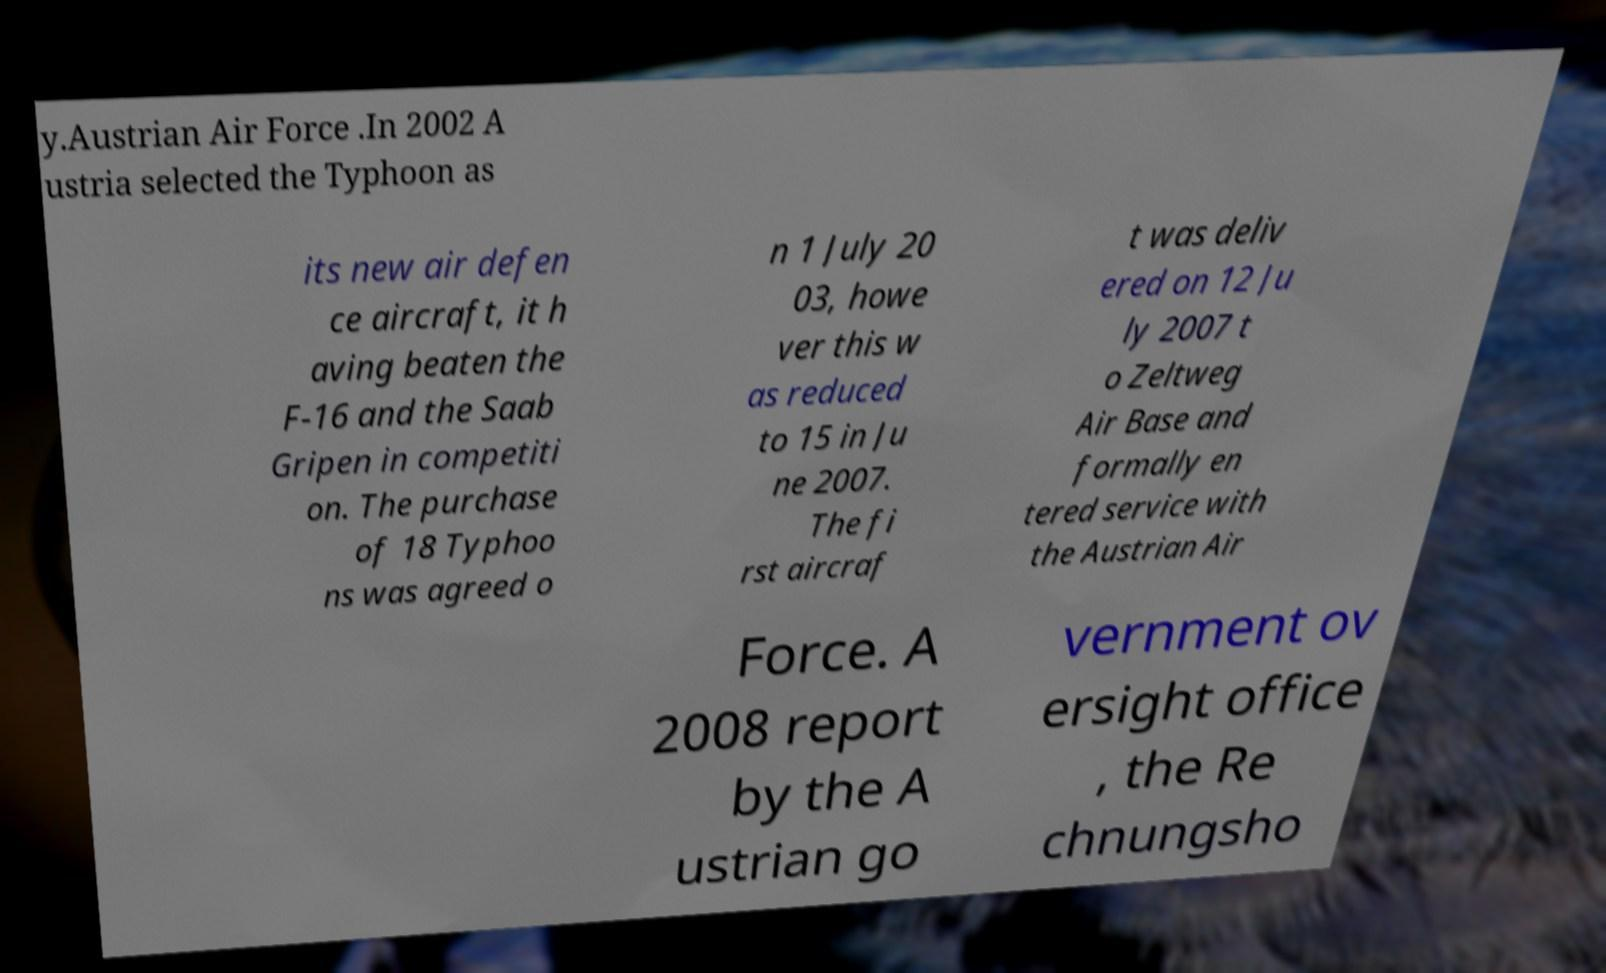What messages or text are displayed in this image? I need them in a readable, typed format. y.Austrian Air Force .In 2002 A ustria selected the Typhoon as its new air defen ce aircraft, it h aving beaten the F-16 and the Saab Gripen in competiti on. The purchase of 18 Typhoo ns was agreed o n 1 July 20 03, howe ver this w as reduced to 15 in Ju ne 2007. The fi rst aircraf t was deliv ered on 12 Ju ly 2007 t o Zeltweg Air Base and formally en tered service with the Austrian Air Force. A 2008 report by the A ustrian go vernment ov ersight office , the Re chnungsho 